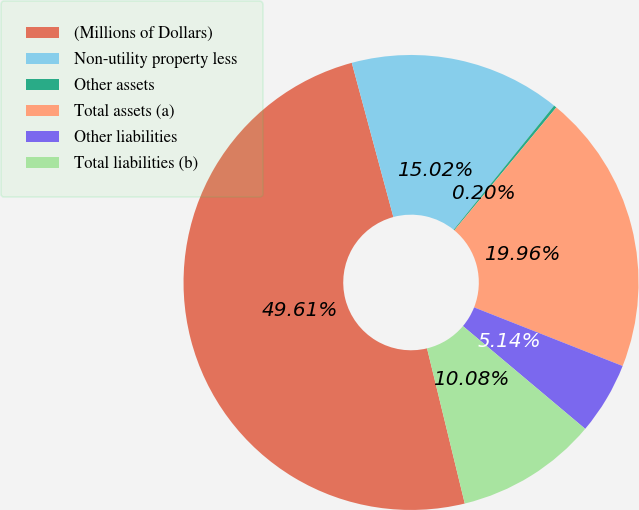<chart> <loc_0><loc_0><loc_500><loc_500><pie_chart><fcel>(Millions of Dollars)<fcel>Non-utility property less<fcel>Other assets<fcel>Total assets (a)<fcel>Other liabilities<fcel>Total liabilities (b)<nl><fcel>49.61%<fcel>15.02%<fcel>0.2%<fcel>19.96%<fcel>5.14%<fcel>10.08%<nl></chart> 